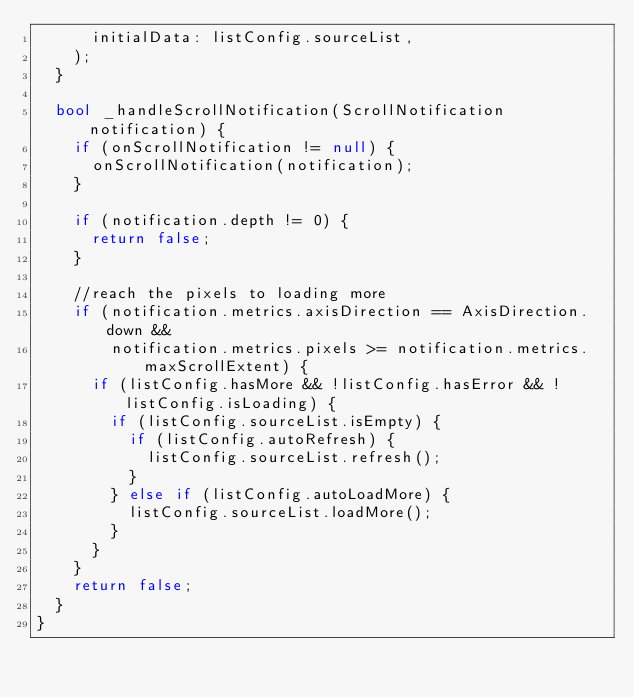<code> <loc_0><loc_0><loc_500><loc_500><_Dart_>      initialData: listConfig.sourceList,
    );
  }

  bool _handleScrollNotification(ScrollNotification notification) {
    if (onScrollNotification != null) {
      onScrollNotification(notification);
    }

    if (notification.depth != 0) {
      return false;
    }

    //reach the pixels to loading more
    if (notification.metrics.axisDirection == AxisDirection.down &&
        notification.metrics.pixels >= notification.metrics.maxScrollExtent) {
      if (listConfig.hasMore && !listConfig.hasError && !listConfig.isLoading) {
        if (listConfig.sourceList.isEmpty) {
          if (listConfig.autoRefresh) {
            listConfig.sourceList.refresh();
          }
        } else if (listConfig.autoLoadMore) {
          listConfig.sourceList.loadMore();
        }
      }
    }
    return false;
  }
}
</code> 